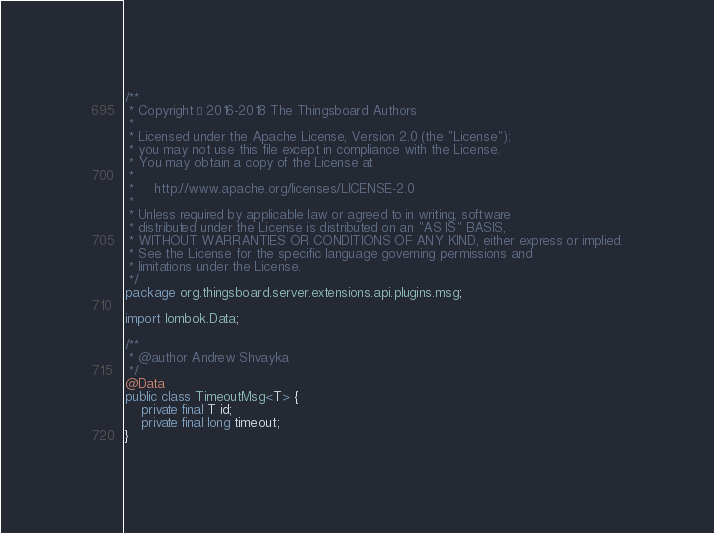Convert code to text. <code><loc_0><loc_0><loc_500><loc_500><_Java_>/**
 * Copyright © 2016-2018 The Thingsboard Authors
 *
 * Licensed under the Apache License, Version 2.0 (the "License");
 * you may not use this file except in compliance with the License.
 * You may obtain a copy of the License at
 *
 *     http://www.apache.org/licenses/LICENSE-2.0
 *
 * Unless required by applicable law or agreed to in writing, software
 * distributed under the License is distributed on an "AS IS" BASIS,
 * WITHOUT WARRANTIES OR CONDITIONS OF ANY KIND, either express or implied.
 * See the License for the specific language governing permissions and
 * limitations under the License.
 */
package org.thingsboard.server.extensions.api.plugins.msg;

import lombok.Data;

/**
 * @author Andrew Shvayka
 */
@Data
public class TimeoutMsg<T> {
    private final T id;
    private final long timeout;
}
</code> 